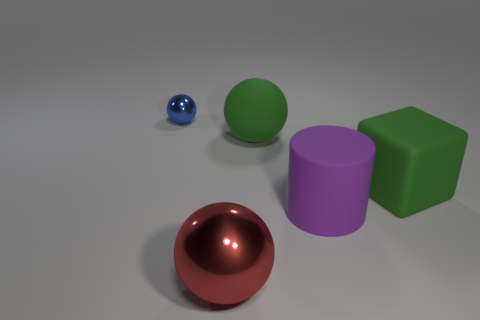Is there a green matte thing that has the same size as the purple object?
Give a very brief answer. Yes. There is a shiny thing that is the same size as the matte cylinder; what is its shape?
Provide a short and direct response. Sphere. How many other things are there of the same color as the large cube?
Your response must be concise. 1. There is a large rubber object that is in front of the rubber sphere and to the left of the block; what shape is it?
Offer a terse response. Cylinder. Is there a tiny shiny object on the left side of the shiny thing in front of the shiny ball that is behind the red sphere?
Your answer should be very brief. Yes. What number of other things are the same material as the purple cylinder?
Keep it short and to the point. 2. What number of large green objects are there?
Your response must be concise. 2. How many objects are large green objects or large shiny balls that are on the left side of the big cylinder?
Your response must be concise. 3. Is there anything else that has the same shape as the large purple thing?
Ensure brevity in your answer.  No. There is a rubber thing left of the purple matte cylinder; does it have the same size as the cube?
Keep it short and to the point. Yes. 